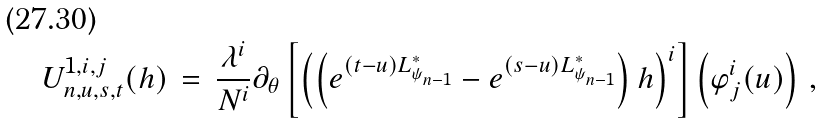<formula> <loc_0><loc_0><loc_500><loc_500>U ^ { 1 , i , j } _ { n , u , s , t } ( h ) \, = \, \frac { \lambda ^ { i } } { N ^ { i } } \partial _ { \theta } \left [ \left ( \left ( e ^ { ( t - u ) L _ { \psi _ { n - 1 } } ^ { * } } - e ^ { ( s - u ) L _ { \psi _ { n - 1 } } ^ { * } } \right ) h \right ) ^ { i } \right ] \left ( \varphi ^ { i } _ { j } ( u ) \right ) \, ,</formula> 